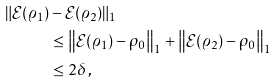Convert formula to latex. <formula><loc_0><loc_0><loc_500><loc_500>\| \mathcal { E } ( \varrho _ { 1 } ) & - \mathcal { E } ( \varrho _ { 2 } ) \| _ { 1 } \\ & \leq \left \| \mathcal { E } ( \varrho _ { 1 } ) - \rho _ { 0 } \right \| _ { 1 } + \left \| \mathcal { E } ( \varrho _ { 2 } ) - \rho _ { 0 } \right \| _ { 1 } \\ & \leq 2 \delta \, ,</formula> 